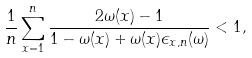Convert formula to latex. <formula><loc_0><loc_0><loc_500><loc_500>\frac { 1 } { n } \sum _ { x = 1 } ^ { n } \frac { 2 \omega ( x ) - 1 } { 1 - \omega ( x ) + \omega ( x ) \epsilon _ { x , n } ( \omega ) } < 1 ,</formula> 